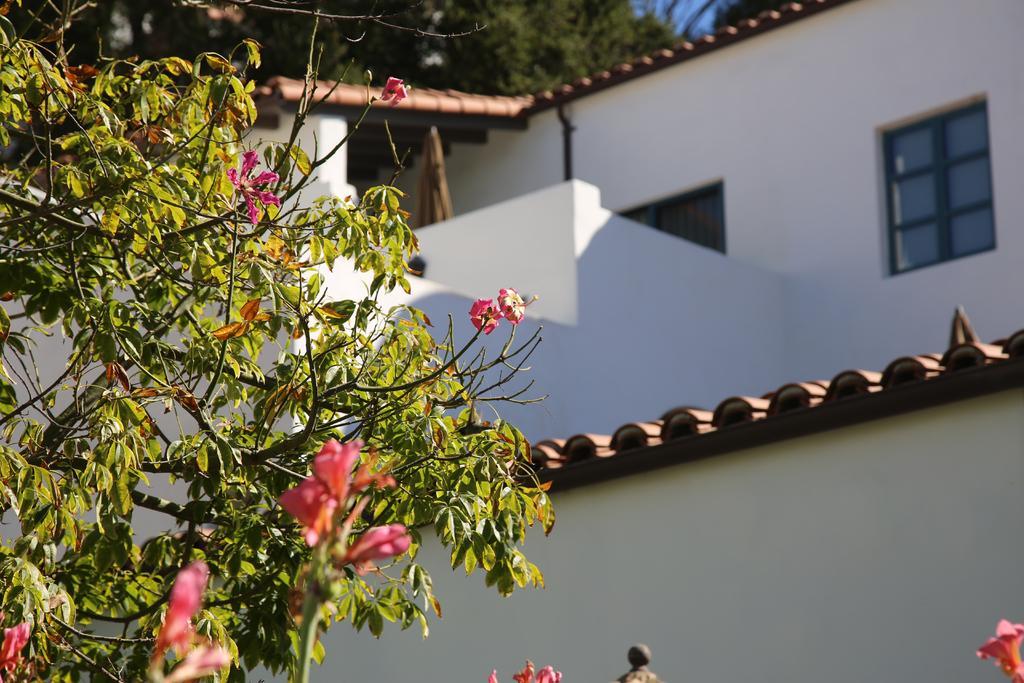Can you describe this image briefly? In this picture we can see a tree with flowers. Behind the tree there is a building, trees and a sky. 